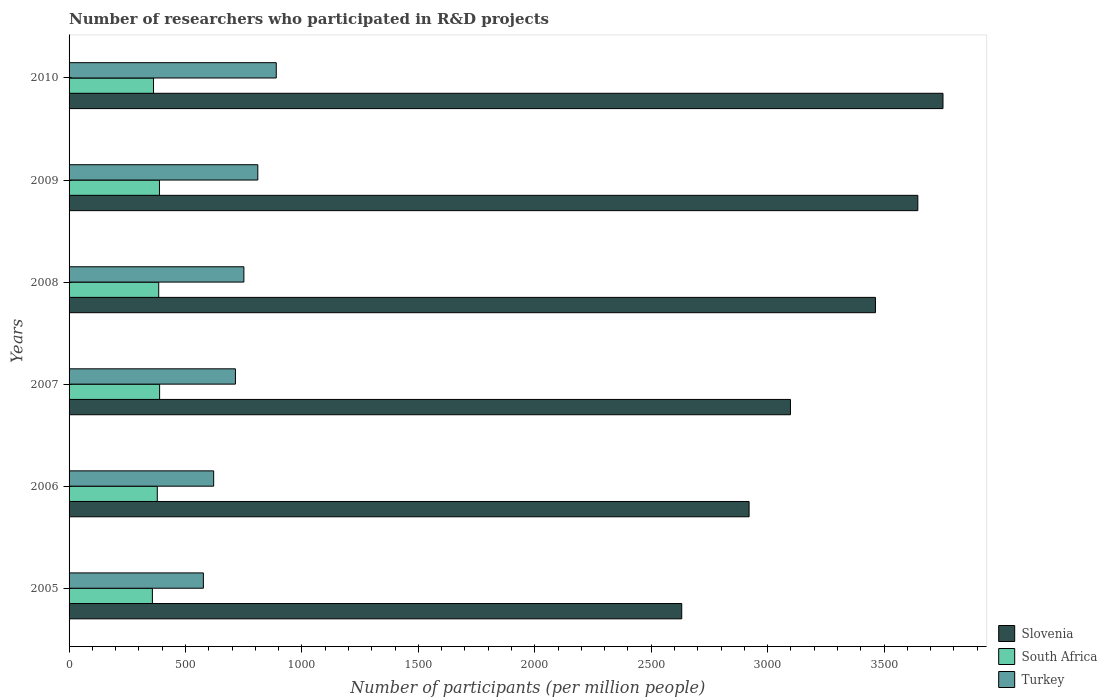How many groups of bars are there?
Ensure brevity in your answer.  6. How many bars are there on the 1st tick from the top?
Your answer should be compact. 3. How many bars are there on the 1st tick from the bottom?
Offer a very short reply. 3. What is the number of researchers who participated in R&D projects in Slovenia in 2010?
Ensure brevity in your answer.  3753.02. Across all years, what is the maximum number of researchers who participated in R&D projects in Turkey?
Offer a very short reply. 889.79. Across all years, what is the minimum number of researchers who participated in R&D projects in Slovenia?
Offer a very short reply. 2631.08. In which year was the number of researchers who participated in R&D projects in Turkey maximum?
Your answer should be compact. 2010. In which year was the number of researchers who participated in R&D projects in Slovenia minimum?
Provide a succinct answer. 2005. What is the total number of researchers who participated in R&D projects in Slovenia in the graph?
Provide a succinct answer. 1.95e+04. What is the difference between the number of researchers who participated in R&D projects in South Africa in 2008 and that in 2009?
Your response must be concise. -3.16. What is the difference between the number of researchers who participated in R&D projects in Slovenia in 2008 and the number of researchers who participated in R&D projects in Turkey in 2007?
Your answer should be compact. 2748.53. What is the average number of researchers who participated in R&D projects in South Africa per year?
Keep it short and to the point. 376.87. In the year 2008, what is the difference between the number of researchers who participated in R&D projects in Slovenia and number of researchers who participated in R&D projects in Turkey?
Provide a succinct answer. 2712.27. What is the ratio of the number of researchers who participated in R&D projects in South Africa in 2008 to that in 2009?
Your answer should be very brief. 0.99. What is the difference between the highest and the second highest number of researchers who participated in R&D projects in Slovenia?
Offer a very short reply. 108.03. What is the difference between the highest and the lowest number of researchers who participated in R&D projects in South Africa?
Offer a terse response. 30.94. Is the sum of the number of researchers who participated in R&D projects in South Africa in 2008 and 2010 greater than the maximum number of researchers who participated in R&D projects in Slovenia across all years?
Provide a succinct answer. No. What does the 3rd bar from the top in 2009 represents?
Provide a short and direct response. Slovenia. What does the 1st bar from the bottom in 2009 represents?
Make the answer very short. Slovenia. Is it the case that in every year, the sum of the number of researchers who participated in R&D projects in South Africa and number of researchers who participated in R&D projects in Turkey is greater than the number of researchers who participated in R&D projects in Slovenia?
Offer a terse response. No. How many bars are there?
Provide a short and direct response. 18. How many years are there in the graph?
Your answer should be very brief. 6. What is the difference between two consecutive major ticks on the X-axis?
Your answer should be very brief. 500. Does the graph contain any zero values?
Offer a terse response. No. Where does the legend appear in the graph?
Your response must be concise. Bottom right. How are the legend labels stacked?
Make the answer very short. Vertical. What is the title of the graph?
Your answer should be compact. Number of researchers who participated in R&D projects. What is the label or title of the X-axis?
Give a very brief answer. Number of participants (per million people). What is the Number of participants (per million people) in Slovenia in 2005?
Your answer should be compact. 2631.08. What is the Number of participants (per million people) in South Africa in 2005?
Offer a very short reply. 357.85. What is the Number of participants (per million people) of Turkey in 2005?
Your answer should be very brief. 576.76. What is the Number of participants (per million people) of Slovenia in 2006?
Provide a succinct answer. 2920.37. What is the Number of participants (per million people) of South Africa in 2006?
Make the answer very short. 378.82. What is the Number of participants (per million people) of Turkey in 2006?
Give a very brief answer. 620.97. What is the Number of participants (per million people) of Slovenia in 2007?
Your answer should be compact. 3097.97. What is the Number of participants (per million people) in South Africa in 2007?
Give a very brief answer. 388.79. What is the Number of participants (per million people) in Turkey in 2007?
Offer a very short reply. 714.49. What is the Number of participants (per million people) in Slovenia in 2008?
Your response must be concise. 3463.02. What is the Number of participants (per million people) of South Africa in 2008?
Keep it short and to the point. 385. What is the Number of participants (per million people) in Turkey in 2008?
Offer a very short reply. 750.75. What is the Number of participants (per million people) of Slovenia in 2009?
Make the answer very short. 3644.99. What is the Number of participants (per million people) in South Africa in 2009?
Offer a very short reply. 388.16. What is the Number of participants (per million people) of Turkey in 2009?
Ensure brevity in your answer.  810.52. What is the Number of participants (per million people) in Slovenia in 2010?
Provide a short and direct response. 3753.02. What is the Number of participants (per million people) of South Africa in 2010?
Give a very brief answer. 362.63. What is the Number of participants (per million people) of Turkey in 2010?
Provide a succinct answer. 889.79. Across all years, what is the maximum Number of participants (per million people) of Slovenia?
Offer a very short reply. 3753.02. Across all years, what is the maximum Number of participants (per million people) of South Africa?
Your answer should be compact. 388.79. Across all years, what is the maximum Number of participants (per million people) in Turkey?
Give a very brief answer. 889.79. Across all years, what is the minimum Number of participants (per million people) of Slovenia?
Keep it short and to the point. 2631.08. Across all years, what is the minimum Number of participants (per million people) in South Africa?
Your answer should be very brief. 357.85. Across all years, what is the minimum Number of participants (per million people) in Turkey?
Keep it short and to the point. 576.76. What is the total Number of participants (per million people) in Slovenia in the graph?
Provide a succinct answer. 1.95e+04. What is the total Number of participants (per million people) of South Africa in the graph?
Provide a short and direct response. 2261.25. What is the total Number of participants (per million people) in Turkey in the graph?
Keep it short and to the point. 4363.26. What is the difference between the Number of participants (per million people) of Slovenia in 2005 and that in 2006?
Offer a very short reply. -289.3. What is the difference between the Number of participants (per million people) of South Africa in 2005 and that in 2006?
Offer a terse response. -20.97. What is the difference between the Number of participants (per million people) in Turkey in 2005 and that in 2006?
Provide a short and direct response. -44.21. What is the difference between the Number of participants (per million people) in Slovenia in 2005 and that in 2007?
Offer a very short reply. -466.89. What is the difference between the Number of participants (per million people) in South Africa in 2005 and that in 2007?
Provide a short and direct response. -30.94. What is the difference between the Number of participants (per million people) in Turkey in 2005 and that in 2007?
Provide a short and direct response. -137.73. What is the difference between the Number of participants (per million people) in Slovenia in 2005 and that in 2008?
Offer a terse response. -831.94. What is the difference between the Number of participants (per million people) of South Africa in 2005 and that in 2008?
Ensure brevity in your answer.  -27.15. What is the difference between the Number of participants (per million people) of Turkey in 2005 and that in 2008?
Give a very brief answer. -173.99. What is the difference between the Number of participants (per million people) in Slovenia in 2005 and that in 2009?
Offer a terse response. -1013.91. What is the difference between the Number of participants (per million people) of South Africa in 2005 and that in 2009?
Provide a short and direct response. -30.31. What is the difference between the Number of participants (per million people) of Turkey in 2005 and that in 2009?
Your answer should be compact. -233.76. What is the difference between the Number of participants (per million people) of Slovenia in 2005 and that in 2010?
Your response must be concise. -1121.95. What is the difference between the Number of participants (per million people) of South Africa in 2005 and that in 2010?
Keep it short and to the point. -4.78. What is the difference between the Number of participants (per million people) in Turkey in 2005 and that in 2010?
Ensure brevity in your answer.  -313.03. What is the difference between the Number of participants (per million people) of Slovenia in 2006 and that in 2007?
Ensure brevity in your answer.  -177.59. What is the difference between the Number of participants (per million people) of South Africa in 2006 and that in 2007?
Your response must be concise. -9.97. What is the difference between the Number of participants (per million people) of Turkey in 2006 and that in 2007?
Your response must be concise. -93.52. What is the difference between the Number of participants (per million people) in Slovenia in 2006 and that in 2008?
Offer a very short reply. -542.64. What is the difference between the Number of participants (per million people) in South Africa in 2006 and that in 2008?
Your answer should be compact. -6.18. What is the difference between the Number of participants (per million people) of Turkey in 2006 and that in 2008?
Offer a very short reply. -129.78. What is the difference between the Number of participants (per million people) of Slovenia in 2006 and that in 2009?
Offer a very short reply. -724.62. What is the difference between the Number of participants (per million people) of South Africa in 2006 and that in 2009?
Provide a short and direct response. -9.34. What is the difference between the Number of participants (per million people) of Turkey in 2006 and that in 2009?
Your answer should be compact. -189.55. What is the difference between the Number of participants (per million people) in Slovenia in 2006 and that in 2010?
Offer a terse response. -832.65. What is the difference between the Number of participants (per million people) in South Africa in 2006 and that in 2010?
Ensure brevity in your answer.  16.19. What is the difference between the Number of participants (per million people) of Turkey in 2006 and that in 2010?
Your response must be concise. -268.82. What is the difference between the Number of participants (per million people) of Slovenia in 2007 and that in 2008?
Keep it short and to the point. -365.05. What is the difference between the Number of participants (per million people) in South Africa in 2007 and that in 2008?
Provide a short and direct response. 3.79. What is the difference between the Number of participants (per million people) in Turkey in 2007 and that in 2008?
Keep it short and to the point. -36.26. What is the difference between the Number of participants (per million people) of Slovenia in 2007 and that in 2009?
Make the answer very short. -547.02. What is the difference between the Number of participants (per million people) in South Africa in 2007 and that in 2009?
Offer a very short reply. 0.63. What is the difference between the Number of participants (per million people) in Turkey in 2007 and that in 2009?
Make the answer very short. -96.03. What is the difference between the Number of participants (per million people) of Slovenia in 2007 and that in 2010?
Offer a terse response. -655.05. What is the difference between the Number of participants (per million people) in South Africa in 2007 and that in 2010?
Your answer should be very brief. 26.16. What is the difference between the Number of participants (per million people) in Turkey in 2007 and that in 2010?
Your answer should be very brief. -175.3. What is the difference between the Number of participants (per million people) of Slovenia in 2008 and that in 2009?
Provide a short and direct response. -181.97. What is the difference between the Number of participants (per million people) in South Africa in 2008 and that in 2009?
Keep it short and to the point. -3.16. What is the difference between the Number of participants (per million people) in Turkey in 2008 and that in 2009?
Make the answer very short. -59.77. What is the difference between the Number of participants (per million people) in Slovenia in 2008 and that in 2010?
Offer a very short reply. -290. What is the difference between the Number of participants (per million people) of South Africa in 2008 and that in 2010?
Provide a succinct answer. 22.37. What is the difference between the Number of participants (per million people) in Turkey in 2008 and that in 2010?
Make the answer very short. -139.04. What is the difference between the Number of participants (per million people) of Slovenia in 2009 and that in 2010?
Provide a succinct answer. -108.03. What is the difference between the Number of participants (per million people) of South Africa in 2009 and that in 2010?
Ensure brevity in your answer.  25.53. What is the difference between the Number of participants (per million people) in Turkey in 2009 and that in 2010?
Provide a succinct answer. -79.27. What is the difference between the Number of participants (per million people) in Slovenia in 2005 and the Number of participants (per million people) in South Africa in 2006?
Offer a terse response. 2252.25. What is the difference between the Number of participants (per million people) of Slovenia in 2005 and the Number of participants (per million people) of Turkey in 2006?
Provide a short and direct response. 2010.11. What is the difference between the Number of participants (per million people) in South Africa in 2005 and the Number of participants (per million people) in Turkey in 2006?
Provide a succinct answer. -263.12. What is the difference between the Number of participants (per million people) of Slovenia in 2005 and the Number of participants (per million people) of South Africa in 2007?
Your response must be concise. 2242.29. What is the difference between the Number of participants (per million people) of Slovenia in 2005 and the Number of participants (per million people) of Turkey in 2007?
Keep it short and to the point. 1916.59. What is the difference between the Number of participants (per million people) in South Africa in 2005 and the Number of participants (per million people) in Turkey in 2007?
Give a very brief answer. -356.64. What is the difference between the Number of participants (per million people) of Slovenia in 2005 and the Number of participants (per million people) of South Africa in 2008?
Give a very brief answer. 2246.07. What is the difference between the Number of participants (per million people) of Slovenia in 2005 and the Number of participants (per million people) of Turkey in 2008?
Give a very brief answer. 1880.33. What is the difference between the Number of participants (per million people) in South Africa in 2005 and the Number of participants (per million people) in Turkey in 2008?
Offer a terse response. -392.9. What is the difference between the Number of participants (per million people) in Slovenia in 2005 and the Number of participants (per million people) in South Africa in 2009?
Make the answer very short. 2242.92. What is the difference between the Number of participants (per million people) of Slovenia in 2005 and the Number of participants (per million people) of Turkey in 2009?
Ensure brevity in your answer.  1820.56. What is the difference between the Number of participants (per million people) in South Africa in 2005 and the Number of participants (per million people) in Turkey in 2009?
Provide a short and direct response. -452.67. What is the difference between the Number of participants (per million people) of Slovenia in 2005 and the Number of participants (per million people) of South Africa in 2010?
Your answer should be compact. 2268.45. What is the difference between the Number of participants (per million people) of Slovenia in 2005 and the Number of participants (per million people) of Turkey in 2010?
Make the answer very short. 1741.29. What is the difference between the Number of participants (per million people) of South Africa in 2005 and the Number of participants (per million people) of Turkey in 2010?
Give a very brief answer. -531.94. What is the difference between the Number of participants (per million people) in Slovenia in 2006 and the Number of participants (per million people) in South Africa in 2007?
Give a very brief answer. 2531.58. What is the difference between the Number of participants (per million people) in Slovenia in 2006 and the Number of participants (per million people) in Turkey in 2007?
Give a very brief answer. 2205.89. What is the difference between the Number of participants (per million people) in South Africa in 2006 and the Number of participants (per million people) in Turkey in 2007?
Keep it short and to the point. -335.67. What is the difference between the Number of participants (per million people) in Slovenia in 2006 and the Number of participants (per million people) in South Africa in 2008?
Your answer should be compact. 2535.37. What is the difference between the Number of participants (per million people) of Slovenia in 2006 and the Number of participants (per million people) of Turkey in 2008?
Offer a very short reply. 2169.62. What is the difference between the Number of participants (per million people) in South Africa in 2006 and the Number of participants (per million people) in Turkey in 2008?
Give a very brief answer. -371.93. What is the difference between the Number of participants (per million people) in Slovenia in 2006 and the Number of participants (per million people) in South Africa in 2009?
Offer a very short reply. 2532.21. What is the difference between the Number of participants (per million people) in Slovenia in 2006 and the Number of participants (per million people) in Turkey in 2009?
Provide a succinct answer. 2109.85. What is the difference between the Number of participants (per million people) in South Africa in 2006 and the Number of participants (per million people) in Turkey in 2009?
Offer a very short reply. -431.7. What is the difference between the Number of participants (per million people) of Slovenia in 2006 and the Number of participants (per million people) of South Africa in 2010?
Give a very brief answer. 2557.74. What is the difference between the Number of participants (per million people) in Slovenia in 2006 and the Number of participants (per million people) in Turkey in 2010?
Your answer should be compact. 2030.58. What is the difference between the Number of participants (per million people) in South Africa in 2006 and the Number of participants (per million people) in Turkey in 2010?
Your answer should be very brief. -510.97. What is the difference between the Number of participants (per million people) of Slovenia in 2007 and the Number of participants (per million people) of South Africa in 2008?
Make the answer very short. 2712.97. What is the difference between the Number of participants (per million people) of Slovenia in 2007 and the Number of participants (per million people) of Turkey in 2008?
Provide a succinct answer. 2347.22. What is the difference between the Number of participants (per million people) of South Africa in 2007 and the Number of participants (per million people) of Turkey in 2008?
Give a very brief answer. -361.96. What is the difference between the Number of participants (per million people) in Slovenia in 2007 and the Number of participants (per million people) in South Africa in 2009?
Your response must be concise. 2709.81. What is the difference between the Number of participants (per million people) in Slovenia in 2007 and the Number of participants (per million people) in Turkey in 2009?
Your answer should be very brief. 2287.45. What is the difference between the Number of participants (per million people) in South Africa in 2007 and the Number of participants (per million people) in Turkey in 2009?
Offer a very short reply. -421.73. What is the difference between the Number of participants (per million people) of Slovenia in 2007 and the Number of participants (per million people) of South Africa in 2010?
Your response must be concise. 2735.34. What is the difference between the Number of participants (per million people) of Slovenia in 2007 and the Number of participants (per million people) of Turkey in 2010?
Your answer should be compact. 2208.18. What is the difference between the Number of participants (per million people) in South Africa in 2007 and the Number of participants (per million people) in Turkey in 2010?
Make the answer very short. -501. What is the difference between the Number of participants (per million people) of Slovenia in 2008 and the Number of participants (per million people) of South Africa in 2009?
Offer a very short reply. 3074.86. What is the difference between the Number of participants (per million people) in Slovenia in 2008 and the Number of participants (per million people) in Turkey in 2009?
Your answer should be very brief. 2652.5. What is the difference between the Number of participants (per million people) in South Africa in 2008 and the Number of participants (per million people) in Turkey in 2009?
Your answer should be compact. -425.52. What is the difference between the Number of participants (per million people) of Slovenia in 2008 and the Number of participants (per million people) of South Africa in 2010?
Offer a very short reply. 3100.39. What is the difference between the Number of participants (per million people) of Slovenia in 2008 and the Number of participants (per million people) of Turkey in 2010?
Keep it short and to the point. 2573.23. What is the difference between the Number of participants (per million people) of South Africa in 2008 and the Number of participants (per million people) of Turkey in 2010?
Your response must be concise. -504.79. What is the difference between the Number of participants (per million people) in Slovenia in 2009 and the Number of participants (per million people) in South Africa in 2010?
Provide a short and direct response. 3282.36. What is the difference between the Number of participants (per million people) in Slovenia in 2009 and the Number of participants (per million people) in Turkey in 2010?
Make the answer very short. 2755.2. What is the difference between the Number of participants (per million people) in South Africa in 2009 and the Number of participants (per million people) in Turkey in 2010?
Offer a very short reply. -501.63. What is the average Number of participants (per million people) of Slovenia per year?
Make the answer very short. 3251.74. What is the average Number of participants (per million people) in South Africa per year?
Offer a terse response. 376.87. What is the average Number of participants (per million people) in Turkey per year?
Make the answer very short. 727.21. In the year 2005, what is the difference between the Number of participants (per million people) in Slovenia and Number of participants (per million people) in South Africa?
Offer a terse response. 2273.23. In the year 2005, what is the difference between the Number of participants (per million people) of Slovenia and Number of participants (per million people) of Turkey?
Provide a short and direct response. 2054.32. In the year 2005, what is the difference between the Number of participants (per million people) in South Africa and Number of participants (per million people) in Turkey?
Provide a short and direct response. -218.91. In the year 2006, what is the difference between the Number of participants (per million people) in Slovenia and Number of participants (per million people) in South Africa?
Give a very brief answer. 2541.55. In the year 2006, what is the difference between the Number of participants (per million people) in Slovenia and Number of participants (per million people) in Turkey?
Provide a succinct answer. 2299.4. In the year 2006, what is the difference between the Number of participants (per million people) in South Africa and Number of participants (per million people) in Turkey?
Your response must be concise. -242.15. In the year 2007, what is the difference between the Number of participants (per million people) in Slovenia and Number of participants (per million people) in South Africa?
Keep it short and to the point. 2709.18. In the year 2007, what is the difference between the Number of participants (per million people) of Slovenia and Number of participants (per million people) of Turkey?
Your response must be concise. 2383.48. In the year 2007, what is the difference between the Number of participants (per million people) in South Africa and Number of participants (per million people) in Turkey?
Make the answer very short. -325.7. In the year 2008, what is the difference between the Number of participants (per million people) of Slovenia and Number of participants (per million people) of South Africa?
Keep it short and to the point. 3078.02. In the year 2008, what is the difference between the Number of participants (per million people) of Slovenia and Number of participants (per million people) of Turkey?
Make the answer very short. 2712.27. In the year 2008, what is the difference between the Number of participants (per million people) in South Africa and Number of participants (per million people) in Turkey?
Keep it short and to the point. -365.75. In the year 2009, what is the difference between the Number of participants (per million people) in Slovenia and Number of participants (per million people) in South Africa?
Make the answer very short. 3256.83. In the year 2009, what is the difference between the Number of participants (per million people) in Slovenia and Number of participants (per million people) in Turkey?
Provide a short and direct response. 2834.47. In the year 2009, what is the difference between the Number of participants (per million people) of South Africa and Number of participants (per million people) of Turkey?
Make the answer very short. -422.36. In the year 2010, what is the difference between the Number of participants (per million people) in Slovenia and Number of participants (per million people) in South Africa?
Offer a terse response. 3390.39. In the year 2010, what is the difference between the Number of participants (per million people) of Slovenia and Number of participants (per million people) of Turkey?
Your answer should be very brief. 2863.23. In the year 2010, what is the difference between the Number of participants (per million people) of South Africa and Number of participants (per million people) of Turkey?
Provide a short and direct response. -527.16. What is the ratio of the Number of participants (per million people) in Slovenia in 2005 to that in 2006?
Provide a short and direct response. 0.9. What is the ratio of the Number of participants (per million people) of South Africa in 2005 to that in 2006?
Offer a terse response. 0.94. What is the ratio of the Number of participants (per million people) of Turkey in 2005 to that in 2006?
Your answer should be very brief. 0.93. What is the ratio of the Number of participants (per million people) of Slovenia in 2005 to that in 2007?
Offer a very short reply. 0.85. What is the ratio of the Number of participants (per million people) of South Africa in 2005 to that in 2007?
Give a very brief answer. 0.92. What is the ratio of the Number of participants (per million people) of Turkey in 2005 to that in 2007?
Offer a terse response. 0.81. What is the ratio of the Number of participants (per million people) in Slovenia in 2005 to that in 2008?
Offer a very short reply. 0.76. What is the ratio of the Number of participants (per million people) of South Africa in 2005 to that in 2008?
Provide a succinct answer. 0.93. What is the ratio of the Number of participants (per million people) of Turkey in 2005 to that in 2008?
Your answer should be compact. 0.77. What is the ratio of the Number of participants (per million people) of Slovenia in 2005 to that in 2009?
Provide a succinct answer. 0.72. What is the ratio of the Number of participants (per million people) in South Africa in 2005 to that in 2009?
Keep it short and to the point. 0.92. What is the ratio of the Number of participants (per million people) in Turkey in 2005 to that in 2009?
Ensure brevity in your answer.  0.71. What is the ratio of the Number of participants (per million people) of Slovenia in 2005 to that in 2010?
Offer a terse response. 0.7. What is the ratio of the Number of participants (per million people) in South Africa in 2005 to that in 2010?
Offer a terse response. 0.99. What is the ratio of the Number of participants (per million people) in Turkey in 2005 to that in 2010?
Offer a very short reply. 0.65. What is the ratio of the Number of participants (per million people) in Slovenia in 2006 to that in 2007?
Give a very brief answer. 0.94. What is the ratio of the Number of participants (per million people) of South Africa in 2006 to that in 2007?
Provide a short and direct response. 0.97. What is the ratio of the Number of participants (per million people) in Turkey in 2006 to that in 2007?
Give a very brief answer. 0.87. What is the ratio of the Number of participants (per million people) of Slovenia in 2006 to that in 2008?
Ensure brevity in your answer.  0.84. What is the ratio of the Number of participants (per million people) of South Africa in 2006 to that in 2008?
Your answer should be very brief. 0.98. What is the ratio of the Number of participants (per million people) in Turkey in 2006 to that in 2008?
Give a very brief answer. 0.83. What is the ratio of the Number of participants (per million people) of Slovenia in 2006 to that in 2009?
Provide a succinct answer. 0.8. What is the ratio of the Number of participants (per million people) in South Africa in 2006 to that in 2009?
Keep it short and to the point. 0.98. What is the ratio of the Number of participants (per million people) in Turkey in 2006 to that in 2009?
Offer a very short reply. 0.77. What is the ratio of the Number of participants (per million people) in Slovenia in 2006 to that in 2010?
Provide a succinct answer. 0.78. What is the ratio of the Number of participants (per million people) in South Africa in 2006 to that in 2010?
Provide a succinct answer. 1.04. What is the ratio of the Number of participants (per million people) of Turkey in 2006 to that in 2010?
Your answer should be very brief. 0.7. What is the ratio of the Number of participants (per million people) of Slovenia in 2007 to that in 2008?
Keep it short and to the point. 0.89. What is the ratio of the Number of participants (per million people) of South Africa in 2007 to that in 2008?
Offer a terse response. 1.01. What is the ratio of the Number of participants (per million people) of Turkey in 2007 to that in 2008?
Keep it short and to the point. 0.95. What is the ratio of the Number of participants (per million people) in Slovenia in 2007 to that in 2009?
Keep it short and to the point. 0.85. What is the ratio of the Number of participants (per million people) of Turkey in 2007 to that in 2009?
Make the answer very short. 0.88. What is the ratio of the Number of participants (per million people) in Slovenia in 2007 to that in 2010?
Ensure brevity in your answer.  0.83. What is the ratio of the Number of participants (per million people) in South Africa in 2007 to that in 2010?
Your answer should be very brief. 1.07. What is the ratio of the Number of participants (per million people) in Turkey in 2007 to that in 2010?
Give a very brief answer. 0.8. What is the ratio of the Number of participants (per million people) of Slovenia in 2008 to that in 2009?
Ensure brevity in your answer.  0.95. What is the ratio of the Number of participants (per million people) of South Africa in 2008 to that in 2009?
Provide a short and direct response. 0.99. What is the ratio of the Number of participants (per million people) of Turkey in 2008 to that in 2009?
Make the answer very short. 0.93. What is the ratio of the Number of participants (per million people) in Slovenia in 2008 to that in 2010?
Ensure brevity in your answer.  0.92. What is the ratio of the Number of participants (per million people) of South Africa in 2008 to that in 2010?
Provide a short and direct response. 1.06. What is the ratio of the Number of participants (per million people) in Turkey in 2008 to that in 2010?
Your response must be concise. 0.84. What is the ratio of the Number of participants (per million people) of Slovenia in 2009 to that in 2010?
Make the answer very short. 0.97. What is the ratio of the Number of participants (per million people) of South Africa in 2009 to that in 2010?
Your response must be concise. 1.07. What is the ratio of the Number of participants (per million people) in Turkey in 2009 to that in 2010?
Give a very brief answer. 0.91. What is the difference between the highest and the second highest Number of participants (per million people) of Slovenia?
Your answer should be compact. 108.03. What is the difference between the highest and the second highest Number of participants (per million people) of South Africa?
Make the answer very short. 0.63. What is the difference between the highest and the second highest Number of participants (per million people) in Turkey?
Your response must be concise. 79.27. What is the difference between the highest and the lowest Number of participants (per million people) of Slovenia?
Ensure brevity in your answer.  1121.95. What is the difference between the highest and the lowest Number of participants (per million people) of South Africa?
Offer a terse response. 30.94. What is the difference between the highest and the lowest Number of participants (per million people) of Turkey?
Make the answer very short. 313.03. 